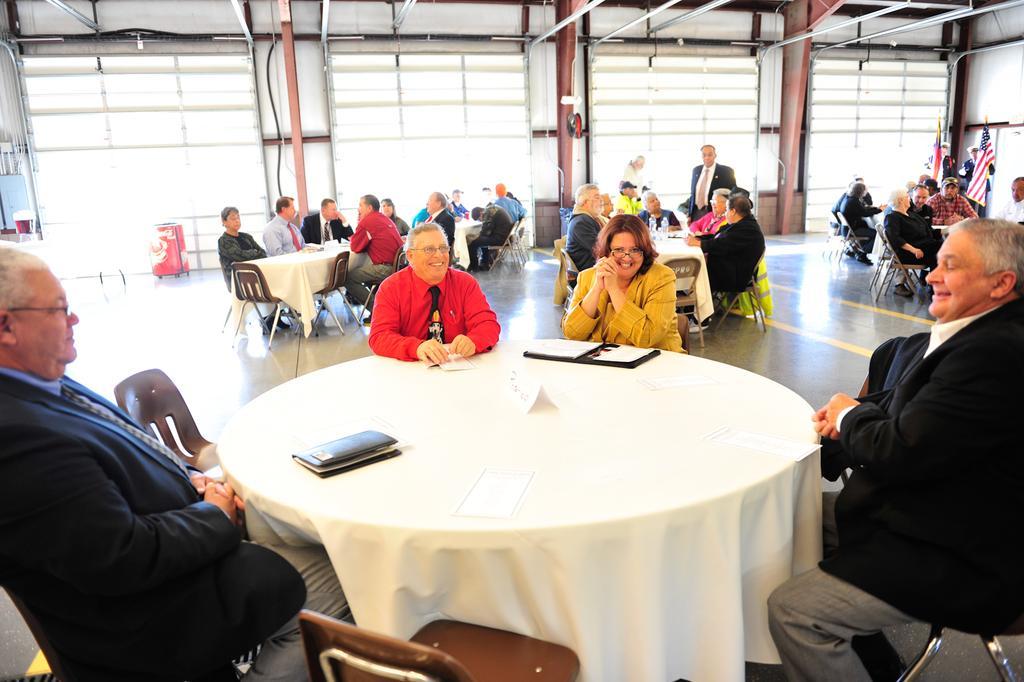In one or two sentences, can you explain what this image depicts? There are many persons sitting on chairs. There are many tables and chairs. On the table there are books. In the background there are flags, windows, tubes and a suitcase. 